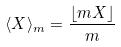Convert formula to latex. <formula><loc_0><loc_0><loc_500><loc_500>\langle X \rangle _ { m } = \frac { \lfloor m X \rfloor } { m }</formula> 